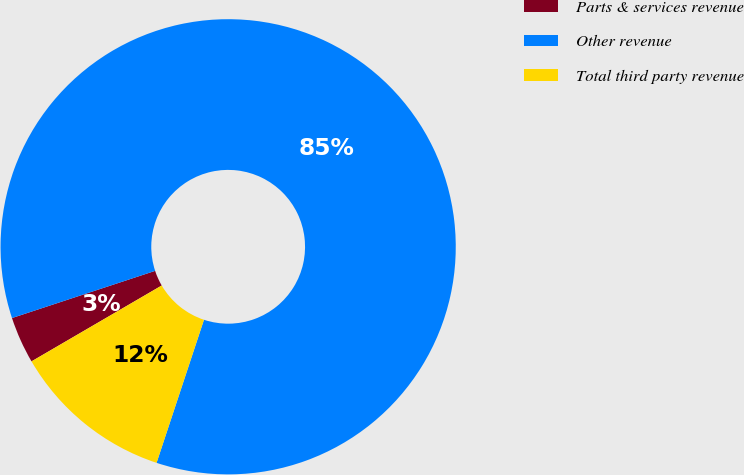<chart> <loc_0><loc_0><loc_500><loc_500><pie_chart><fcel>Parts & services revenue<fcel>Other revenue<fcel>Total third party revenue<nl><fcel>3.33%<fcel>85.16%<fcel>11.51%<nl></chart> 